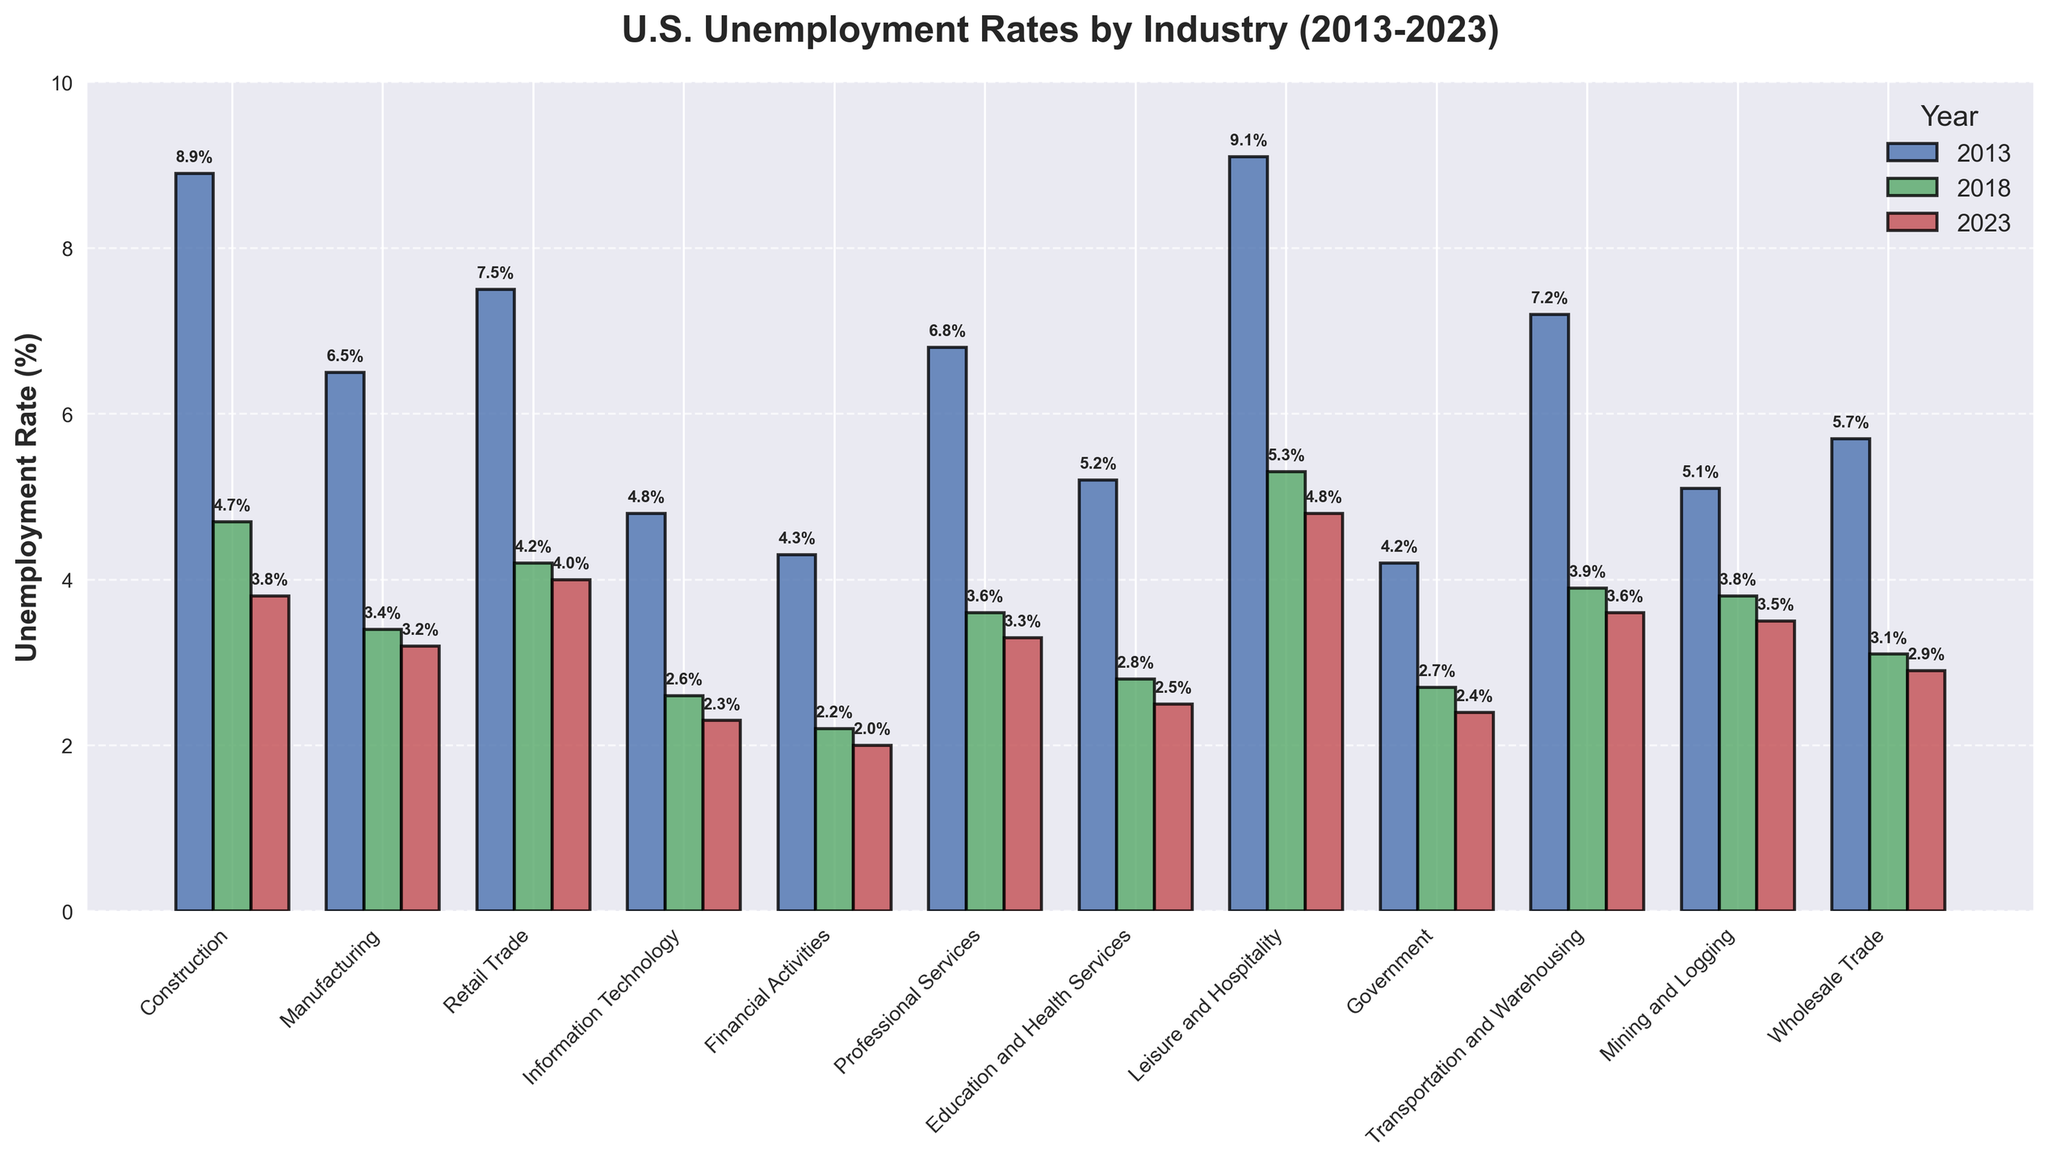Which industry had the highest unemployment rate in 2013? To identify the highest unemployment rate in 2013, we need to examine the bar heights for all industries in the year 2013 and find the maximum. Construction had the highest unemployment rate in 2013.
Answer: Construction Which industry saw the most significant decrease in unemployment rate between 2013 and 2023? Calculate the decrease for each industry by subtracting the 2023 rate from the 2013 rate, then find the greatest value. Construction had the most significant decrease in unemployment rate, from 8.9% in 2013 to 3.8% in 2023, a decrease of 5.1%.
Answer: Construction Which industry had the smallest change in unemployment rate from 2013 to 2023? Calculate the change for each industry by subtracting the 2023 rate from the 2013 rate, then find the smallest absolute change. Financial Activities had the smallest change, from 4.3% in 2013 to 2.0% in 2023, a change of 2.3%.
Answer: Financial Activities In which year did the Education and Health Services industry have the lowest unemployment rate? Compare the unemployment rates of the Education and Health Services industry for the years 2013, 2018, and 2023 and identify the smallest rate. The lowest unemployment rate for Education and Health Services was in 2023, at 2.5%.
Answer: 2023 Did the Retail Trade industry have a higher unemployment rate in 2018 or 2023? Compare the bar heights for the Retail Trade industry between 2018 and 2023 to determine which year had a higher rate. The Retail Trade industry had a higher unemployment rate in 2018, at 4.2%.
Answer: 2018 Which year had the lowest overall unemployment rates across all industries? Compare the height of bars for each year (2013, 2018, 2023) across all industries and determine the year with the lowest bar heights overall. The year with the lowest overall unemployment rates across industries is 2023.
Answer: 2023 What is the average unemployment rate for the Government sector over the three years? Add the unemployment rates for 2013, 2018, and 2023 for the Government sector and divide by three. The average is (4.2% + 2.7% + 2.4%) / 3 = 3.1%.
Answer: 3.1% How does the 2023 unemployment rate for Mining and Logging compare to Professional Services in the same year? Compare the bar heights for Mining and Logging and Professional Services in 2023. Mining and Logging had an unemployment rate of 3.5%, while Professional Services had an unemployment rate of 3.3% in 2023.
Answer: Mining and Logging had a slightly higher rate Does the Leisure and Hospitality industry have the highest unemployment rate in every year shown? Examine the relative heights of the bars for Leisure and Hospitality compared to other bars in 2013, 2018, and 2023. The Leisure and Hospitality industry had the highest rate in 2013, but not in 2018 and 2023.
Answer: No How much did the unemployment rate for the Professional Services industry decrease from 2018 to 2023? Subtract the Professional Services unemployment rate in 2023 from its rate in 2018. The decrease is 3.6% - 3.3% = 0.3%.
Answer: 0.3% 